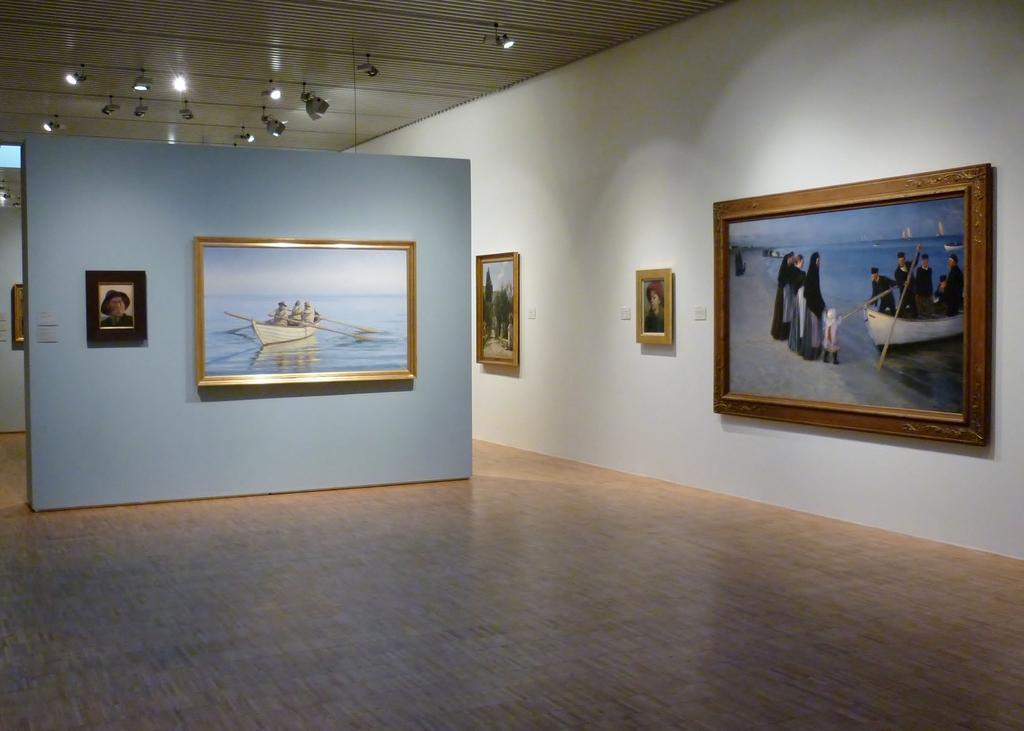How would you summarize this image in a sentence or two? There is a hall, in which, there are photo frames on white color wall and on blue color walls which are arranged on the floor, above them, there are lights attached to the roof. 